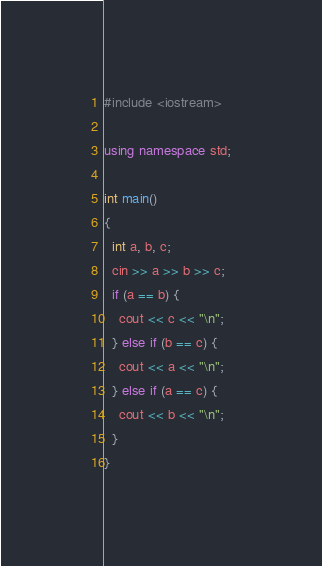Convert code to text. <code><loc_0><loc_0><loc_500><loc_500><_C++_>#include <iostream>

using namespace std;

int main()
{    
  int a, b, c;
  cin >> a >> b >> c;
  if (a == b) {
    cout << c << "\n";
  } else if (b == c) {
    cout << a << "\n";
  } else if (a == c) {
    cout << b << "\n";
  }
}</code> 